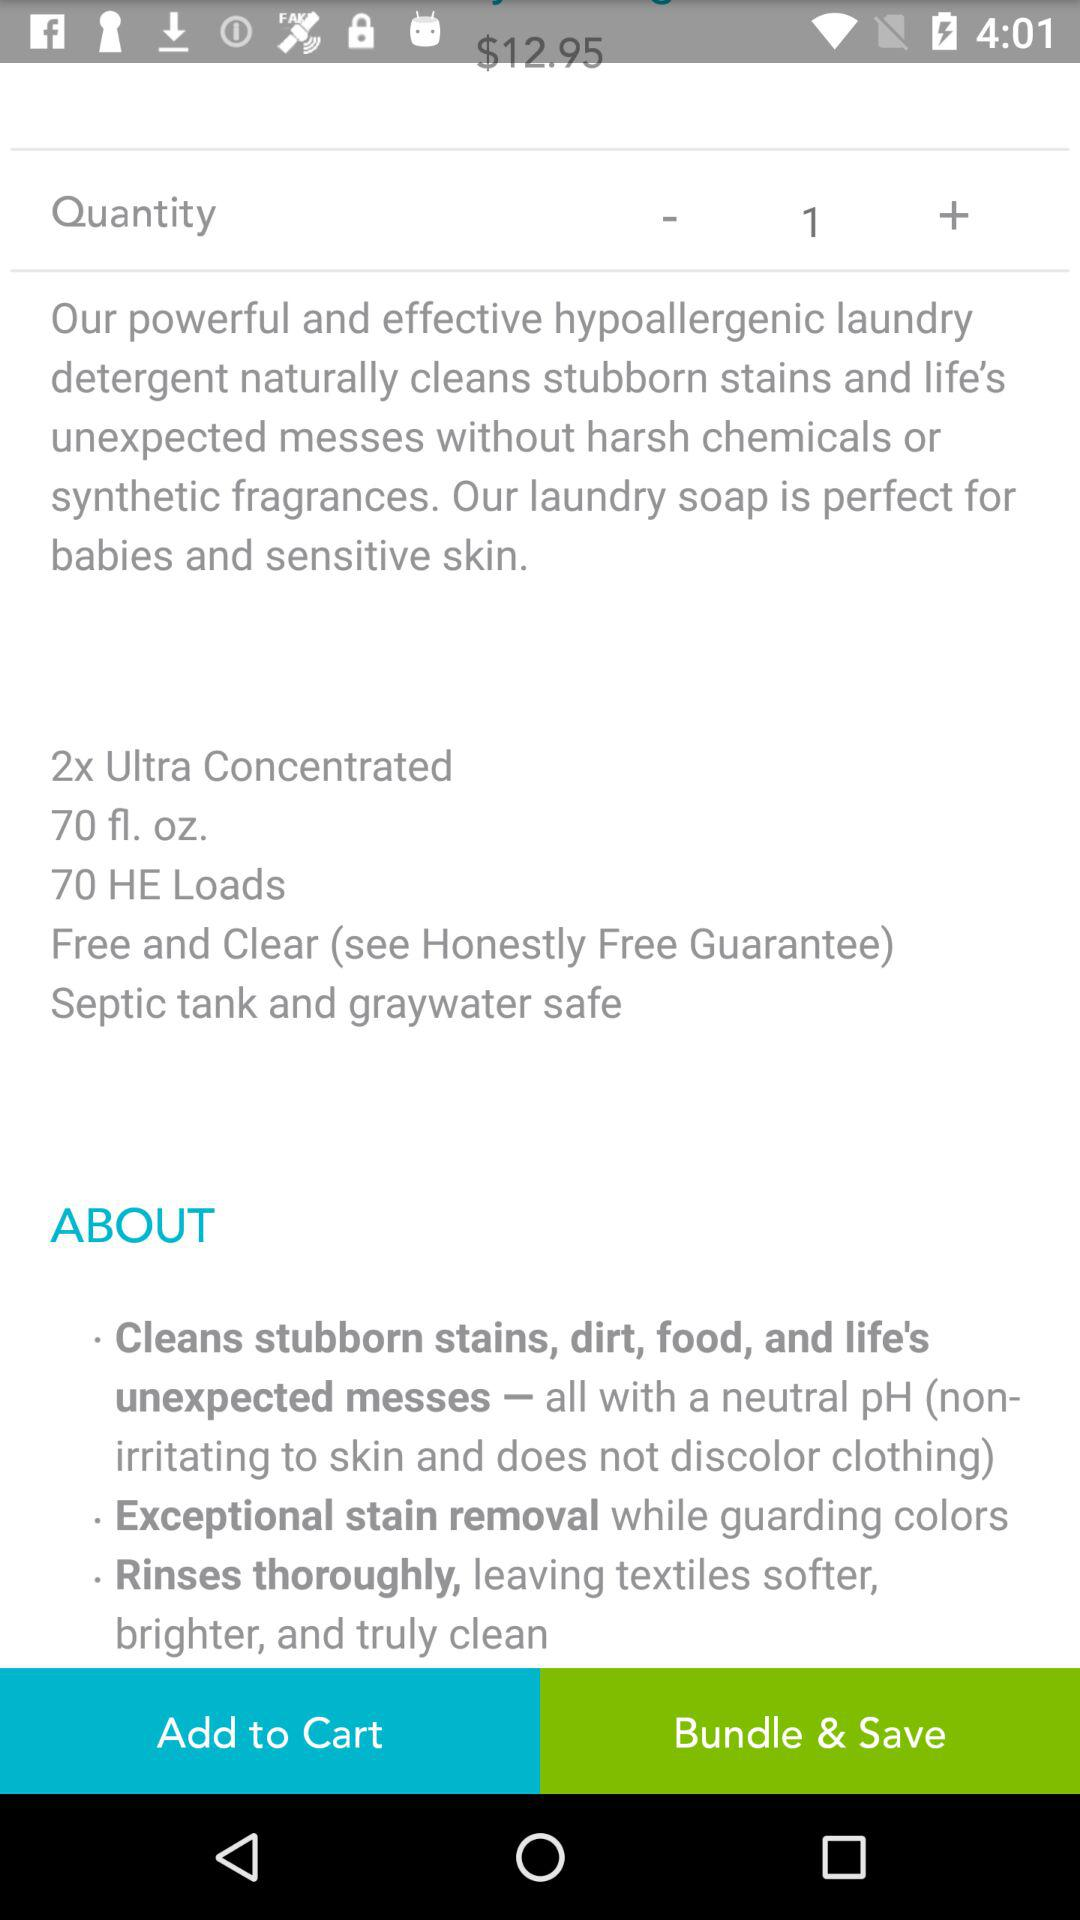What is the price of "detergent"? The price is $12.95. 